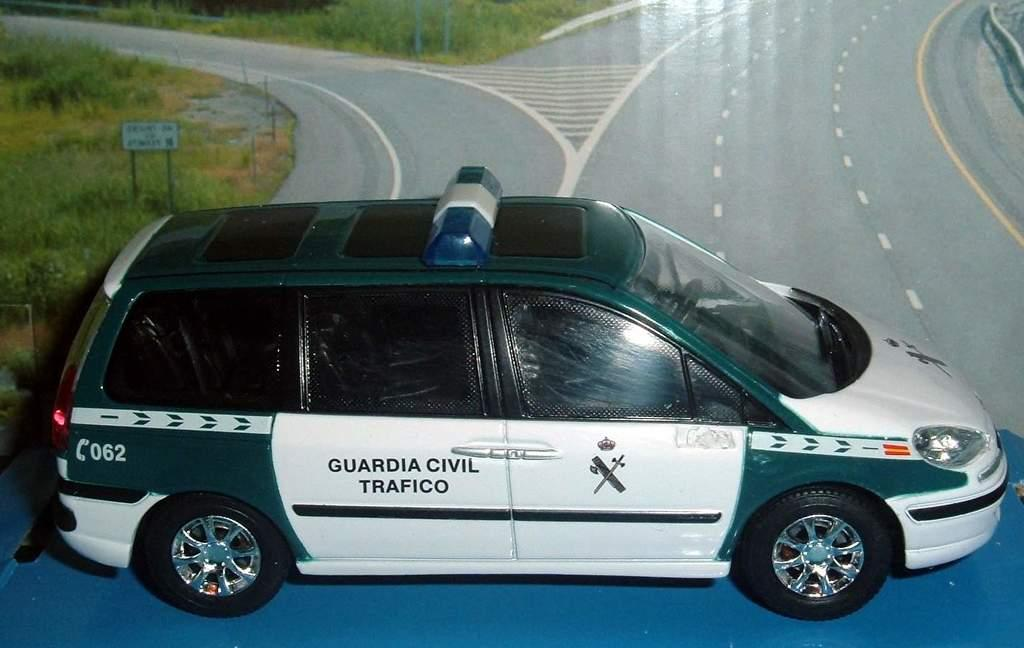<image>
Render a clear and concise summary of the photo. a car that has the word trafico on it 